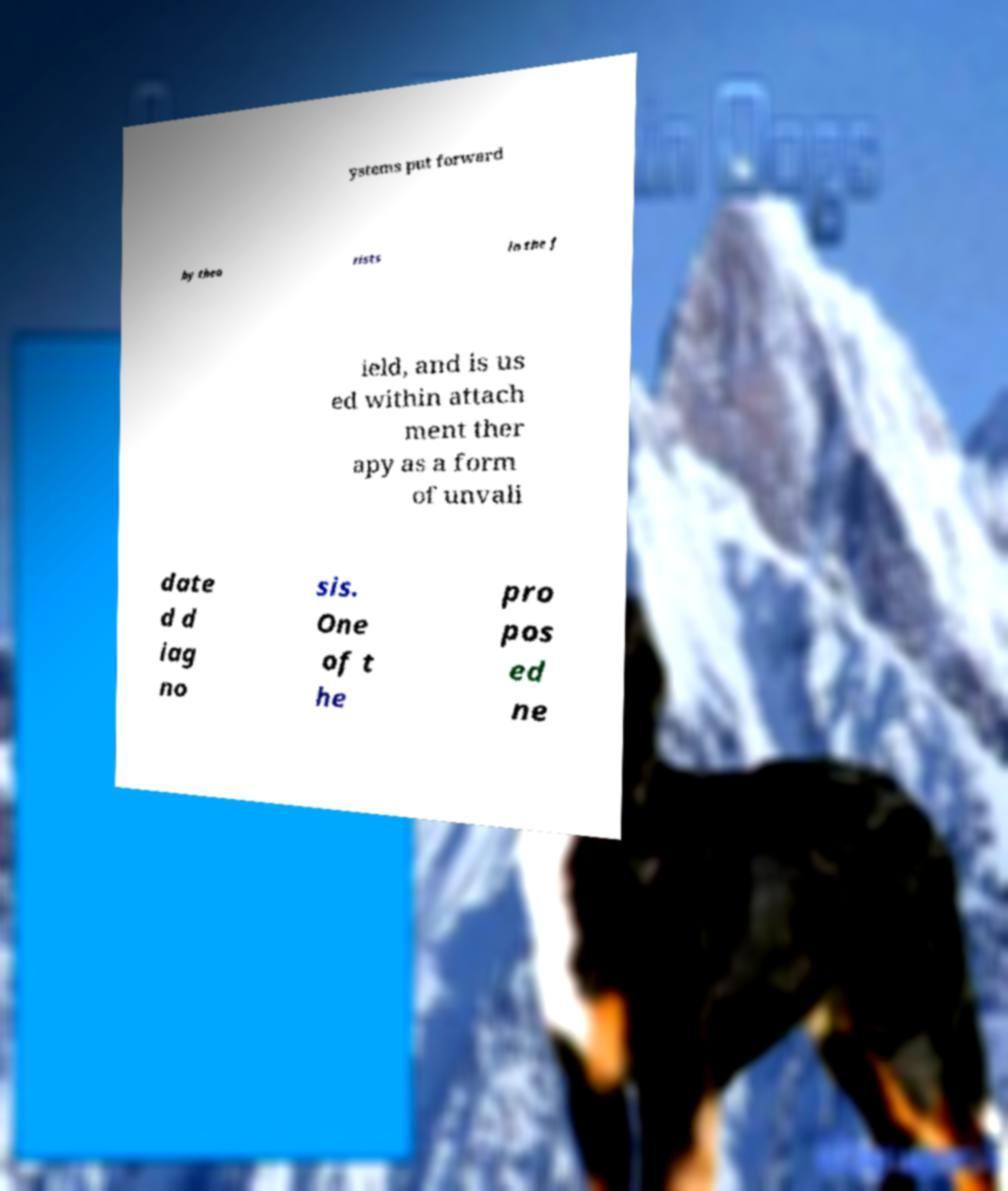Please identify and transcribe the text found in this image. ystems put forward by theo rists in the f ield, and is us ed within attach ment ther apy as a form of unvali date d d iag no sis. One of t he pro pos ed ne 